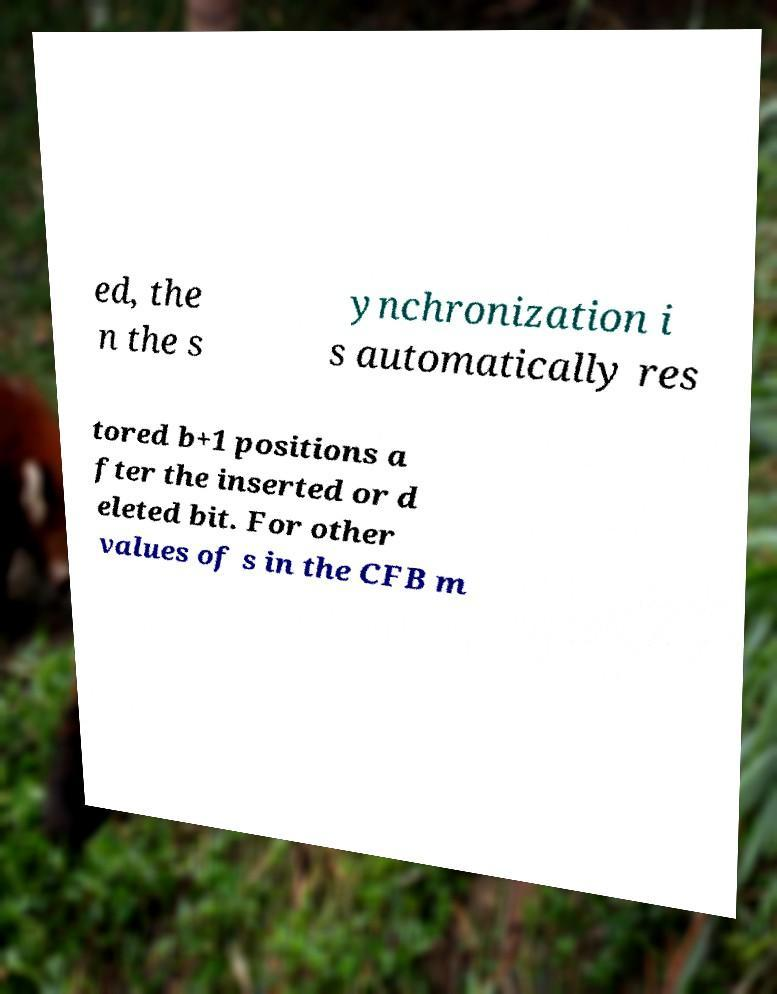Please read and relay the text visible in this image. What does it say? ed, the n the s ynchronization i s automatically res tored b+1 positions a fter the inserted or d eleted bit. For other values of s in the CFB m 